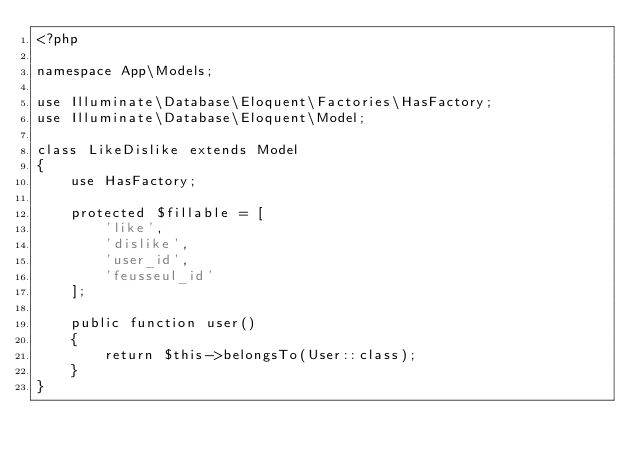<code> <loc_0><loc_0><loc_500><loc_500><_PHP_><?php

namespace App\Models;

use Illuminate\Database\Eloquent\Factories\HasFactory;
use Illuminate\Database\Eloquent\Model;

class LikeDislike extends Model
{
    use HasFactory;

    protected $fillable = [
        'like',
        'dislike',
        'user_id',
        'feusseul_id'
    ];

    public function user()
    {
        return $this->belongsTo(User::class);
    }
}
</code> 